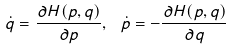<formula> <loc_0><loc_0><loc_500><loc_500>\dot { q } = \frac { \partial H ( p , q ) } { \partial p } , \ \dot { p } = - \frac { \partial H ( p , q ) } { \partial q }</formula> 